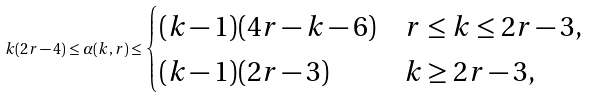<formula> <loc_0><loc_0><loc_500><loc_500>k ( 2 r - 4 ) \leq \alpha ( k , r ) \leq \begin{cases} ( k - 1 ) ( 4 r - k - 6 ) & r \leq k \leq 2 r - 3 , \\ ( k - 1 ) ( 2 r - 3 ) & k \geq 2 r - 3 , \end{cases}</formula> 